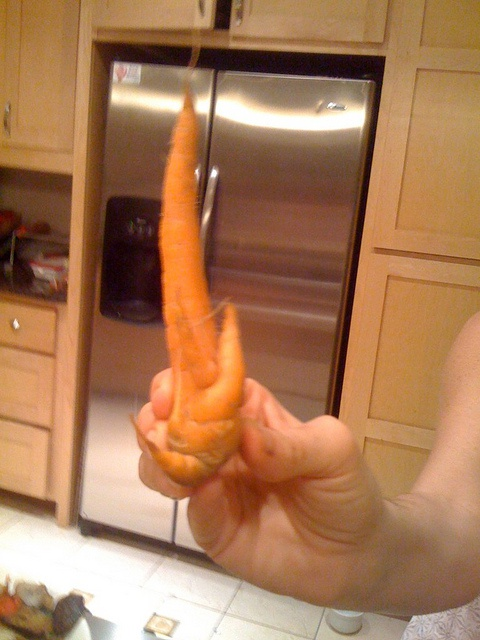Describe the objects in this image and their specific colors. I can see refrigerator in olive, brown, gray, and maroon tones, people in olive, gray, brown, and tan tones, carrot in olive, red, orange, and brown tones, and bowl in olive, darkgray, and gray tones in this image. 